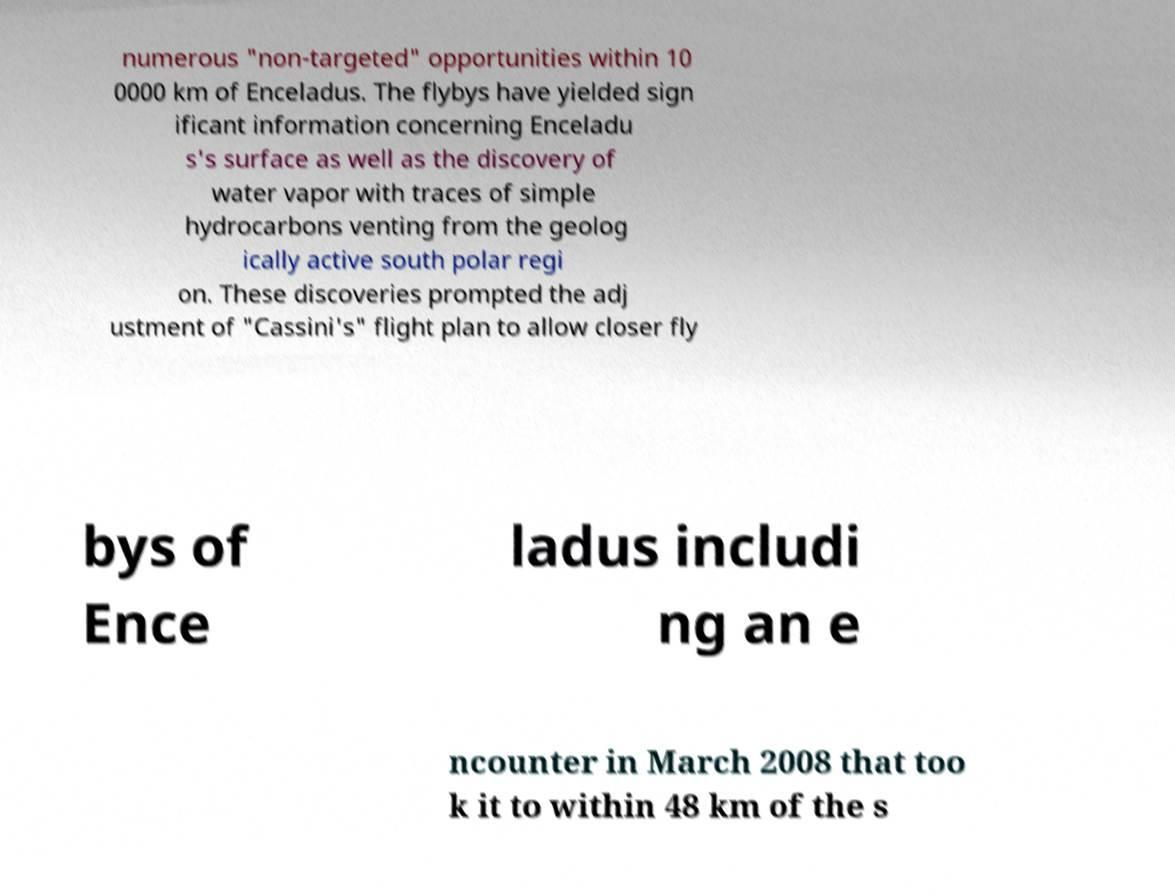Please read and relay the text visible in this image. What does it say? numerous "non-targeted" opportunities within 10 0000 km of Enceladus. The flybys have yielded sign ificant information concerning Enceladu s's surface as well as the discovery of water vapor with traces of simple hydrocarbons venting from the geolog ically active south polar regi on. These discoveries prompted the adj ustment of "Cassini's" flight plan to allow closer fly bys of Ence ladus includi ng an e ncounter in March 2008 that too k it to within 48 km of the s 